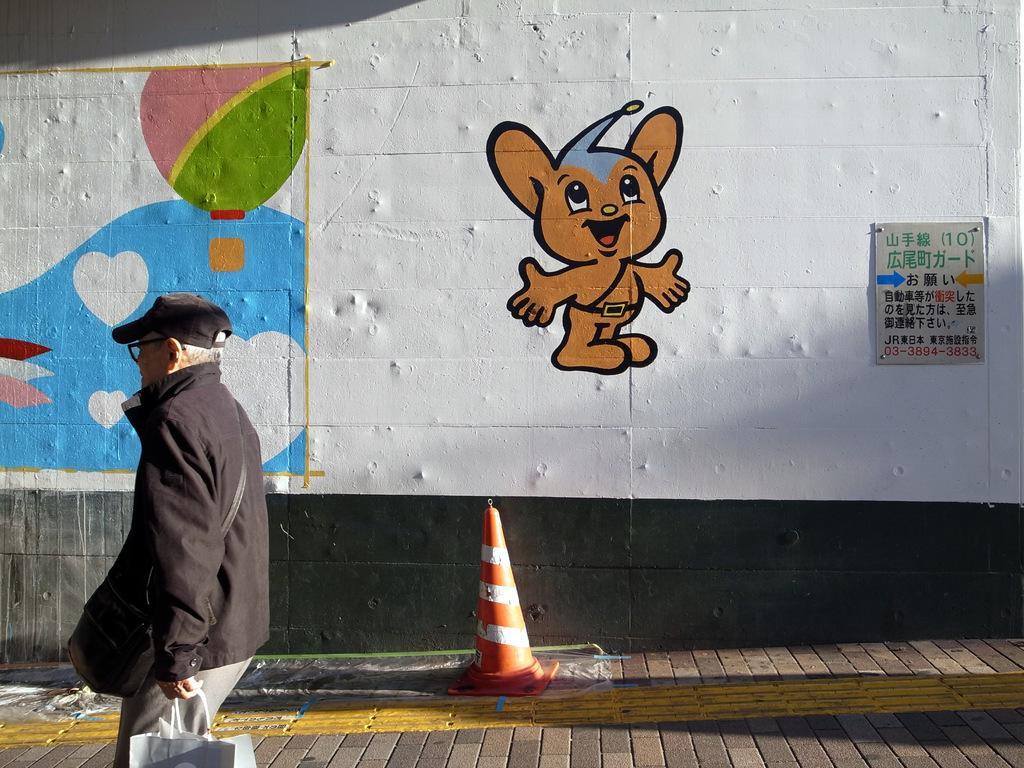How would you summarize this image in a sentence or two? In this picture I can see a man standing and holding a bag, there is a cone bar barricade, and in the background there are paintings and a board on the wall. 